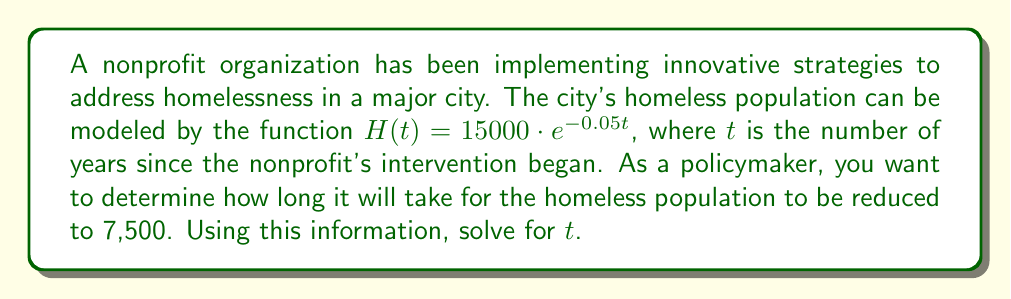Teach me how to tackle this problem. Let's approach this step-by-step:

1) We start with the given function: $H(t) = 15000 \cdot e^{-0.05t}$

2) We want to find $t$ when $H(t) = 7500$. So, let's set up the equation:

   $7500 = 15000 \cdot e^{-0.05t}$

3) Divide both sides by 15000:

   $\frac{7500}{15000} = e^{-0.05t}$

4) Simplify:

   $0.5 = e^{-0.05t}$

5) Take the natural logarithm of both sides:

   $\ln(0.5) = \ln(e^{-0.05t})$

6) Simplify the right side using the property of logarithms:

   $\ln(0.5) = -0.05t$

7) Divide both sides by -0.05:

   $\frac{\ln(0.5)}{-0.05} = t$

8) Calculate:

   $t = \frac{\ln(0.5)}{-0.05} \approx 13.86$

Therefore, it will take approximately 13.86 years for the homeless population to be reduced to 7,500.
Answer: $13.86$ years 